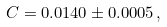Convert formula to latex. <formula><loc_0><loc_0><loc_500><loc_500>C = 0 . 0 1 4 0 \pm 0 . 0 0 0 5 \, ,</formula> 